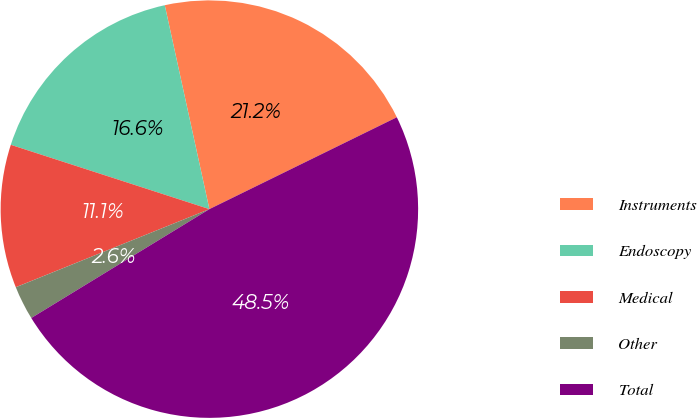Convert chart to OTSL. <chart><loc_0><loc_0><loc_500><loc_500><pie_chart><fcel>Instruments<fcel>Endoscopy<fcel>Medical<fcel>Other<fcel>Total<nl><fcel>21.18%<fcel>16.59%<fcel>11.09%<fcel>2.63%<fcel>48.53%<nl></chart> 